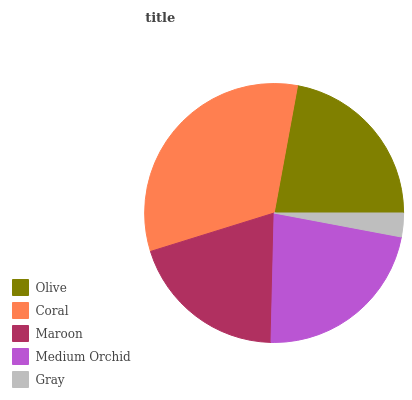Is Gray the minimum?
Answer yes or no. Yes. Is Coral the maximum?
Answer yes or no. Yes. Is Maroon the minimum?
Answer yes or no. No. Is Maroon the maximum?
Answer yes or no. No. Is Coral greater than Maroon?
Answer yes or no. Yes. Is Maroon less than Coral?
Answer yes or no. Yes. Is Maroon greater than Coral?
Answer yes or no. No. Is Coral less than Maroon?
Answer yes or no. No. Is Olive the high median?
Answer yes or no. Yes. Is Olive the low median?
Answer yes or no. Yes. Is Gray the high median?
Answer yes or no. No. Is Medium Orchid the low median?
Answer yes or no. No. 